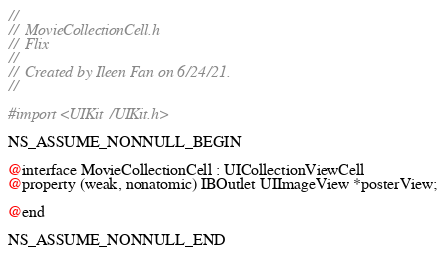Convert code to text. <code><loc_0><loc_0><loc_500><loc_500><_C_>//
//  MovieCollectionCell.h
//  Flix
//
//  Created by Ileen Fan on 6/24/21.
//

#import <UIKit/UIKit.h>

NS_ASSUME_NONNULL_BEGIN

@interface MovieCollectionCell : UICollectionViewCell
@property (weak, nonatomic) IBOutlet UIImageView *posterView;

@end

NS_ASSUME_NONNULL_END
</code> 